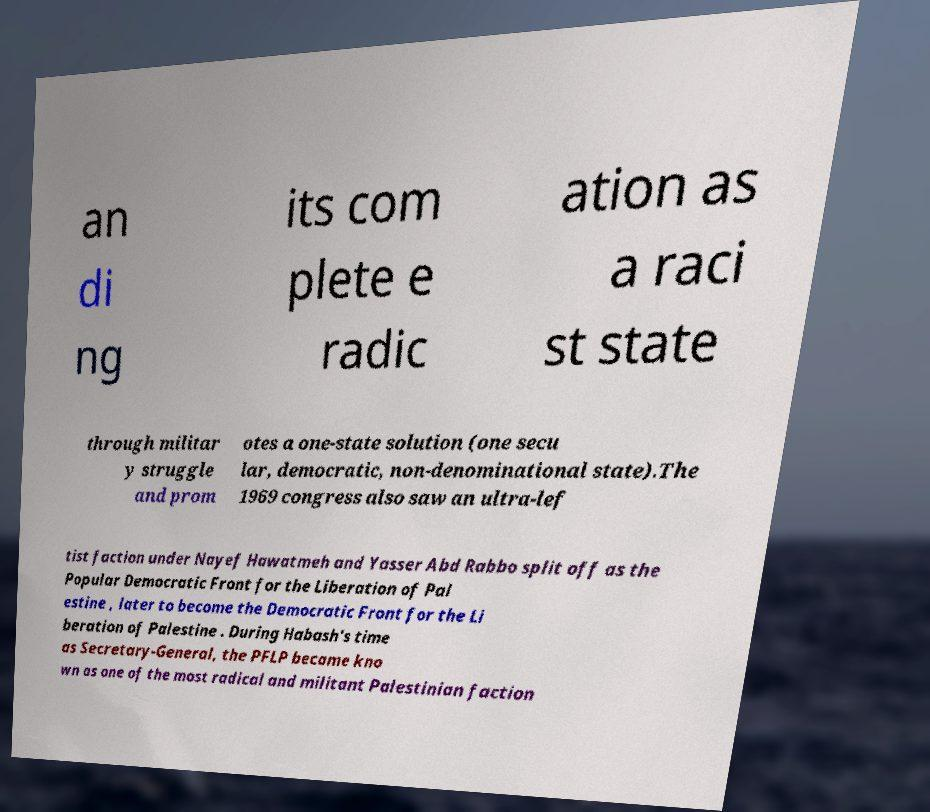I need the written content from this picture converted into text. Can you do that? an di ng its com plete e radic ation as a raci st state through militar y struggle and prom otes a one-state solution (one secu lar, democratic, non-denominational state).The 1969 congress also saw an ultra-lef tist faction under Nayef Hawatmeh and Yasser Abd Rabbo split off as the Popular Democratic Front for the Liberation of Pal estine , later to become the Democratic Front for the Li beration of Palestine . During Habash's time as Secretary-General, the PFLP became kno wn as one of the most radical and militant Palestinian faction 